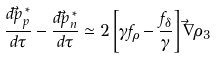<formula> <loc_0><loc_0><loc_500><loc_500>\frac { { d \vec { p } } ^ { \, * } _ { p } } { d \tau } - \frac { { d \vec { p } } ^ { \, * } _ { n } } { d \tau } \simeq 2 \left [ \gamma f _ { \rho } - \frac { f _ { \delta } } { \gamma } \right ] \vec { \nabla } \rho _ { 3 }</formula> 